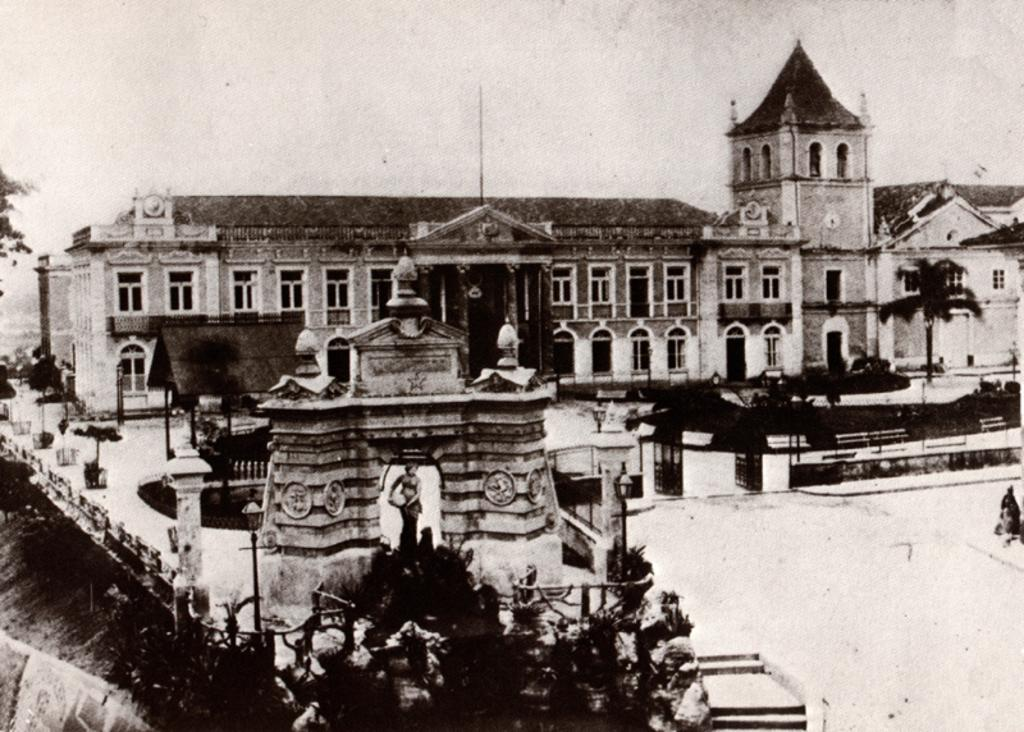What is the color scheme of the image? The image is black and white. What type of structure can be seen in the image? There is a building in the image. What type of vegetation is present in the image? There is a tree in the image. How many dogs are visible in the image? There are no dogs present in the image. Is there a horse running in the background of the image? There is no horse present in the image. 